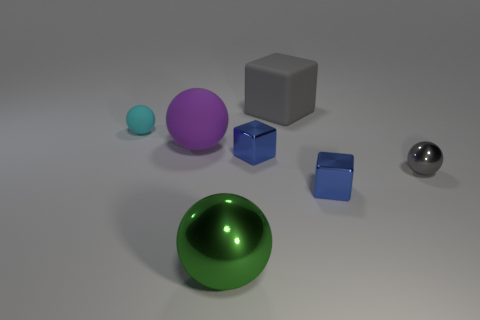There is a rubber object on the right side of the purple ball; is it the same color as the tiny sphere that is right of the big purple rubber thing?
Offer a very short reply. Yes. The rubber object that is the same color as the small shiny ball is what size?
Offer a very short reply. Large. How many small objects have the same color as the large cube?
Offer a very short reply. 1. What is the size of the green thing that is made of the same material as the tiny gray thing?
Your answer should be compact. Large. What number of things are tiny things left of the large gray thing or green blocks?
Ensure brevity in your answer.  2. Do the metal ball on the right side of the big rubber cube and the large cube have the same color?
Give a very brief answer. Yes. What size is the green metallic thing that is the same shape as the purple object?
Ensure brevity in your answer.  Large. There is a small cube that is in front of the gray thing in front of the object behind the tiny rubber object; what is its color?
Your answer should be compact. Blue. Does the large purple object have the same material as the big gray thing?
Your response must be concise. Yes. Is there a small blue metal cube that is behind the small blue metallic cube that is behind the tiny ball to the right of the green metallic sphere?
Your response must be concise. No. 